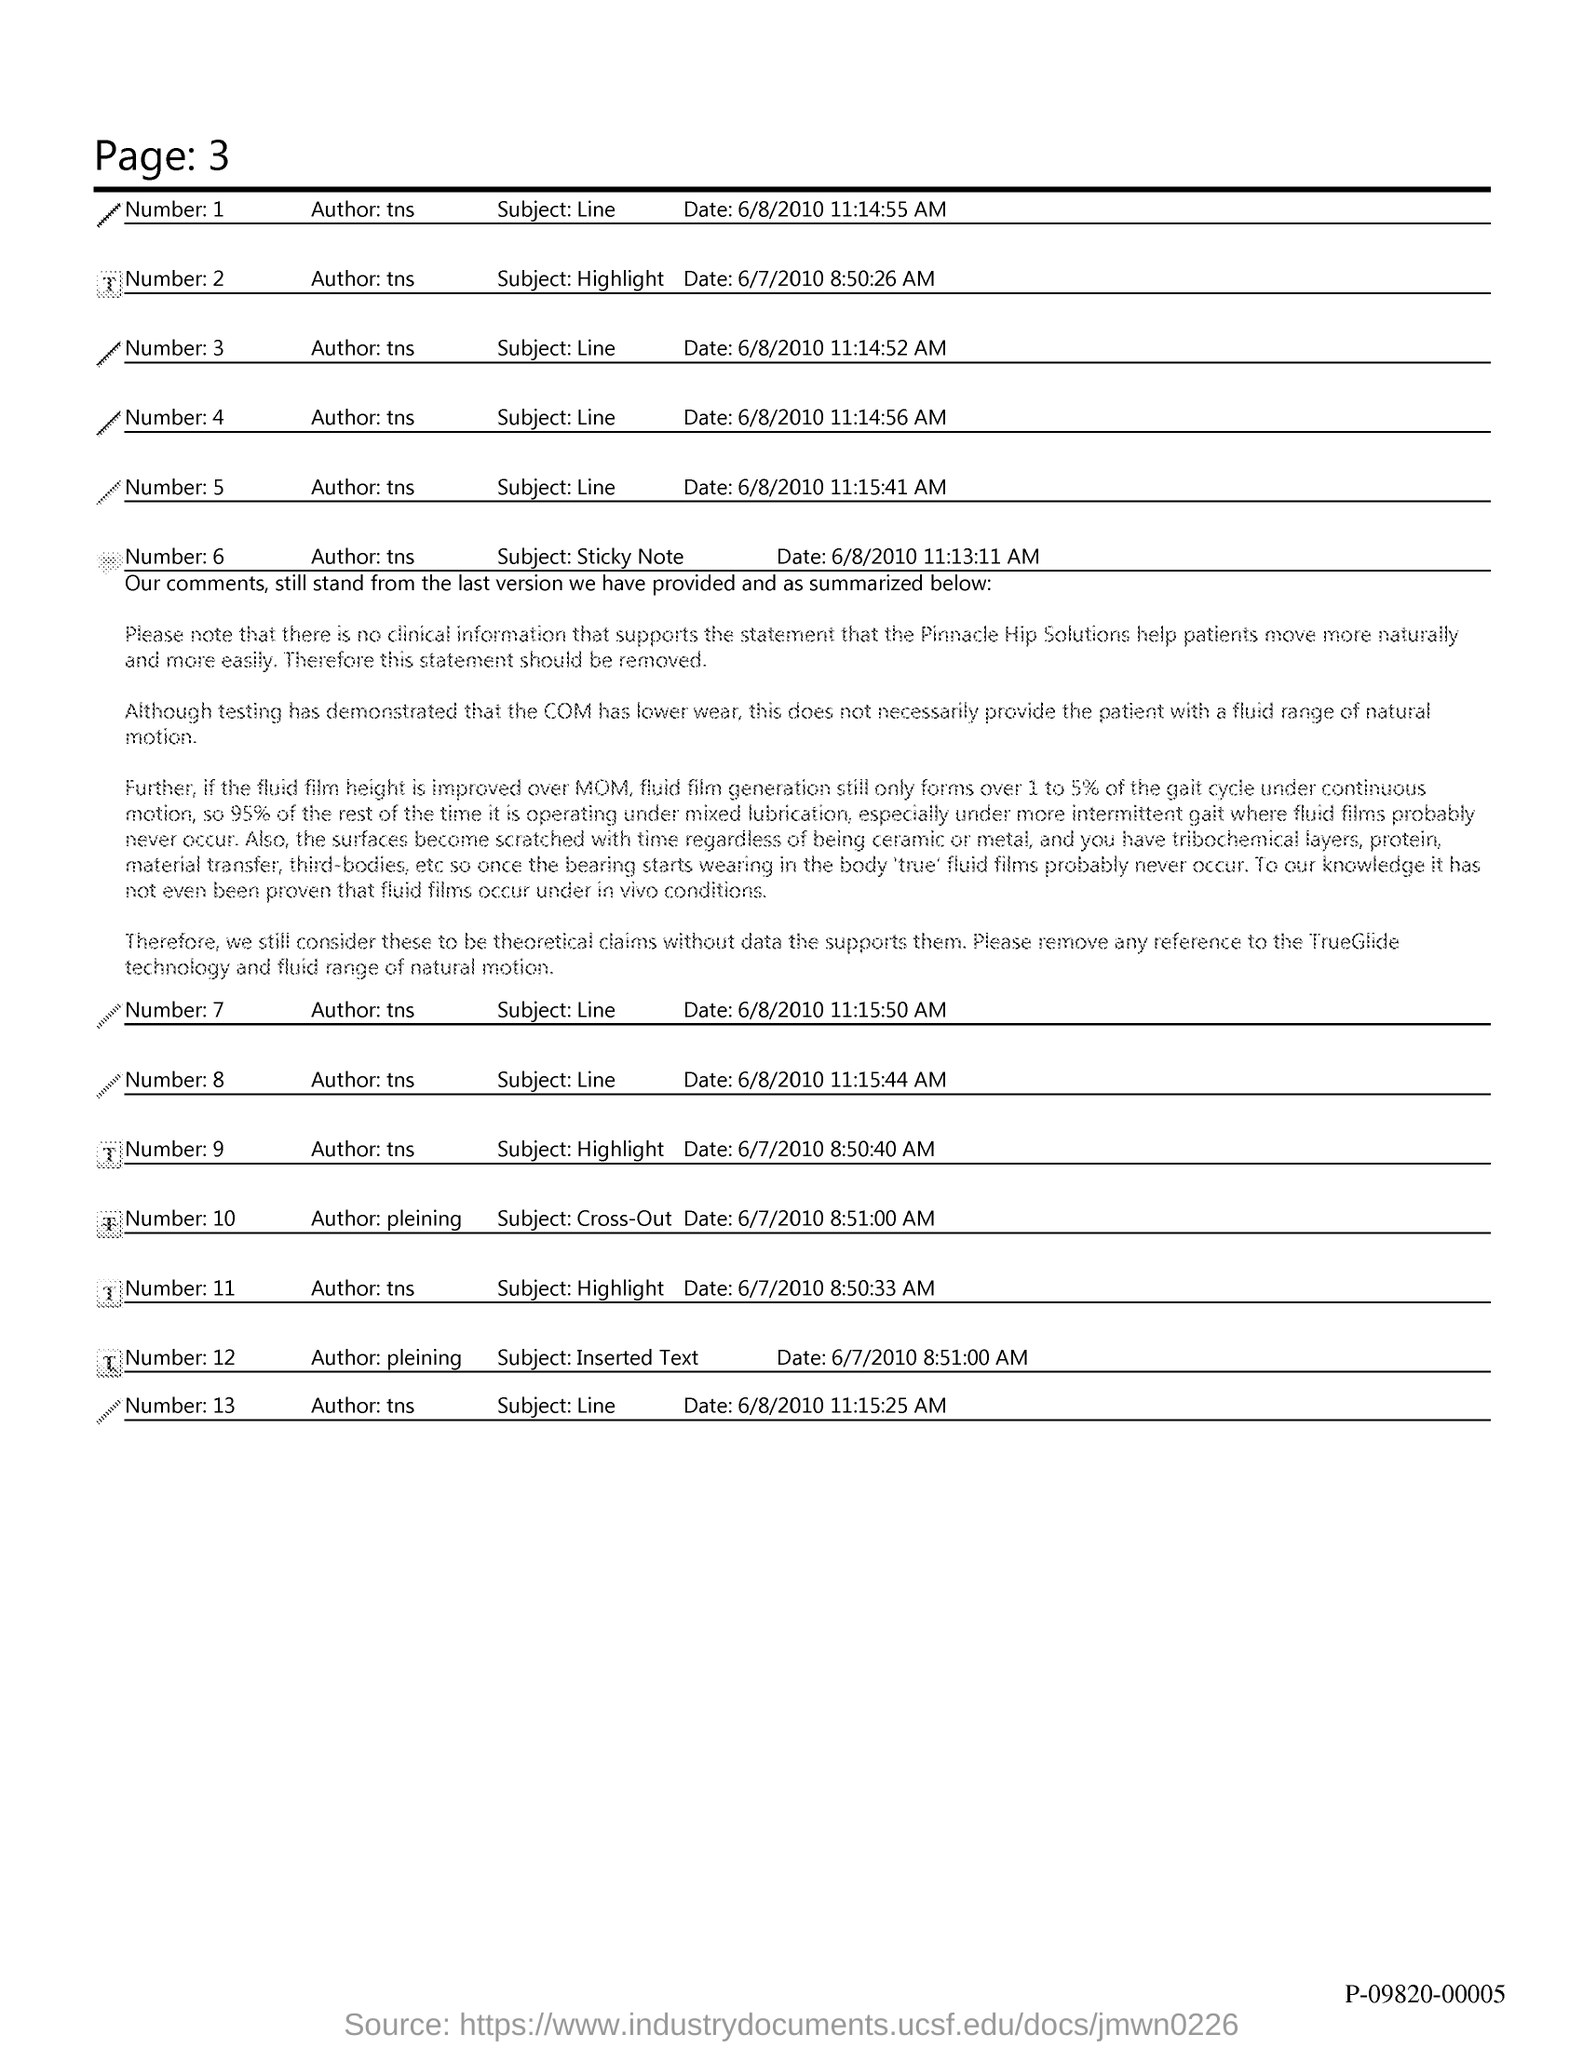Mention a couple of crucial points in this snapshot. What is the subject mentioned with Number 3 in Line X? The subject mentioned with number 6 is a sticky note. 